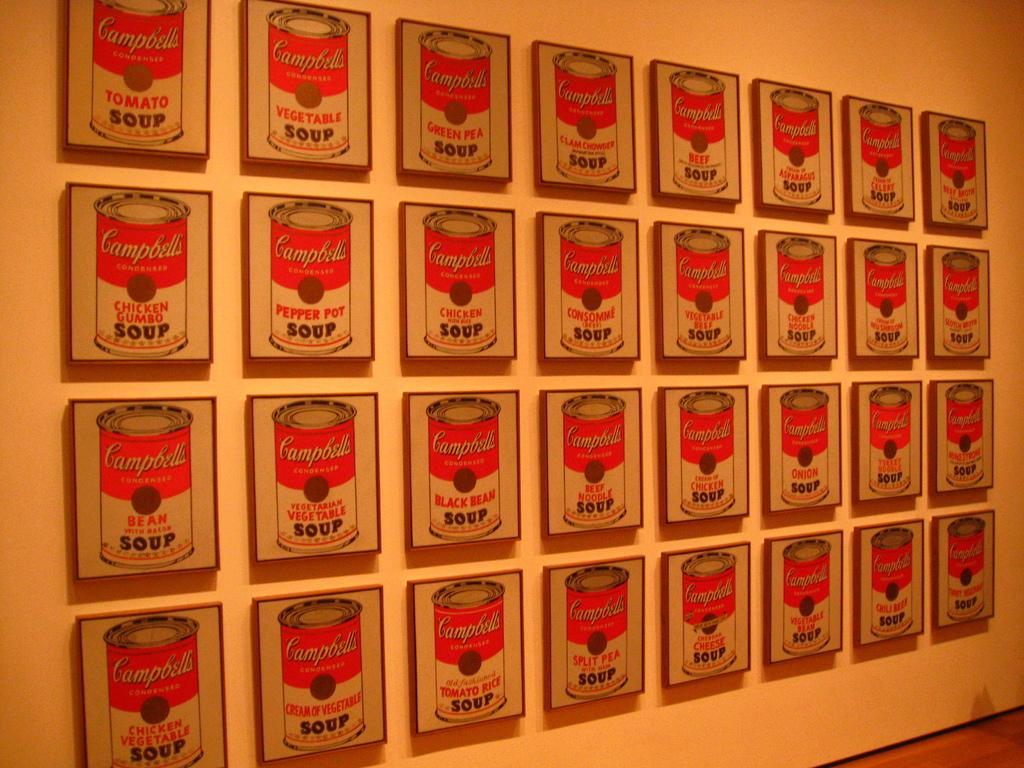<image>
Share a concise interpretation of the image provided. A wall many framed drawings of different varieties of Campbells Condensed soup, including Vegetable, Pepper Pot, and Black Bean. 